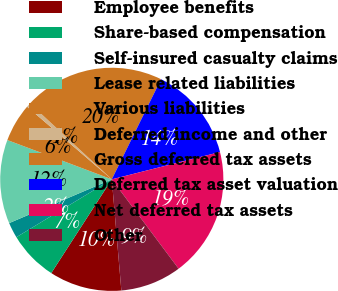Convert chart to OTSL. <chart><loc_0><loc_0><loc_500><loc_500><pie_chart><fcel>Employee benefits<fcel>Share-based compensation<fcel>Self-insured casualty claims<fcel>Lease related liabilities<fcel>Various liabilities<fcel>Deferred income and other<fcel>Gross deferred tax assets<fcel>Deferred tax asset valuation<fcel>Net deferred tax assets<fcel>Other<nl><fcel>10.49%<fcel>7.2%<fcel>2.26%<fcel>12.14%<fcel>5.56%<fcel>0.62%<fcel>20.37%<fcel>13.79%<fcel>18.72%<fcel>8.85%<nl></chart> 